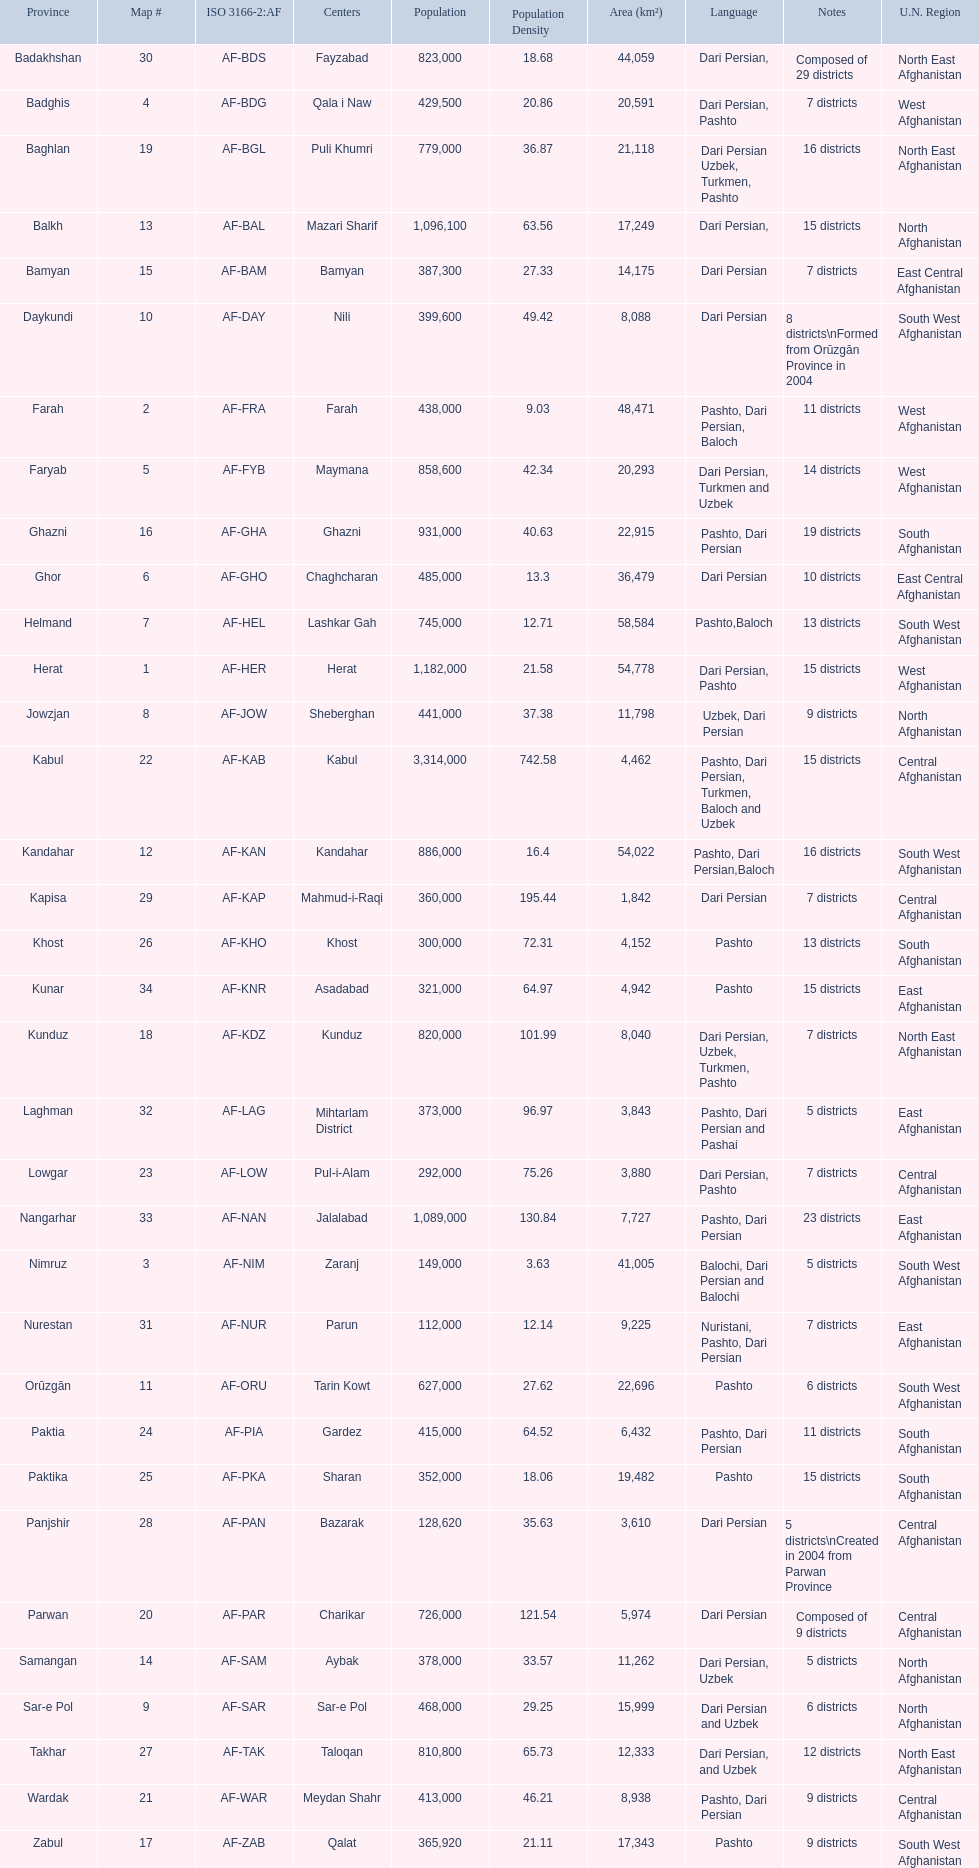How many districts are in the province of kunduz? 7. 